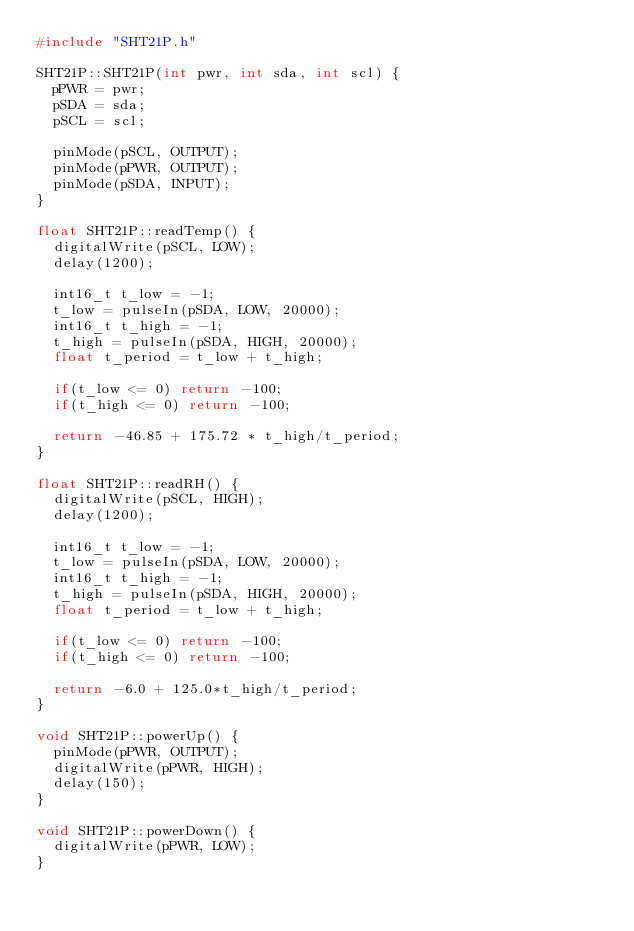Convert code to text. <code><loc_0><loc_0><loc_500><loc_500><_C++_>#include "SHT21P.h"

SHT21P::SHT21P(int pwr, int sda, int scl) {
  pPWR = pwr;
  pSDA = sda;
  pSCL = scl;

  pinMode(pSCL, OUTPUT);
  pinMode(pPWR, OUTPUT);
  pinMode(pSDA, INPUT);
}

float SHT21P::readTemp() {
  digitalWrite(pSCL, LOW);
  delay(1200);
  
  int16_t t_low = -1;
  t_low = pulseIn(pSDA, LOW, 20000);
  int16_t t_high = -1;
  t_high = pulseIn(pSDA, HIGH, 20000);
  float t_period = t_low + t_high;

  if(t_low <= 0) return -100;
  if(t_high <= 0) return -100;

  return -46.85 + 175.72 * t_high/t_period;
}

float SHT21P::readRH() {
  digitalWrite(pSCL, HIGH);
  delay(1200);
  
  int16_t t_low = -1;
  t_low = pulseIn(pSDA, LOW, 20000);
  int16_t t_high = -1;
  t_high = pulseIn(pSDA, HIGH, 20000);
  float t_period = t_low + t_high;

  if(t_low <= 0) return -100;
  if(t_high <= 0) return -100;

  return -6.0 + 125.0*t_high/t_period;
}

void SHT21P::powerUp() {
  pinMode(pPWR, OUTPUT);
  digitalWrite(pPWR, HIGH);
  delay(150);
}

void SHT21P::powerDown() {
  digitalWrite(pPWR, LOW);
}
</code> 